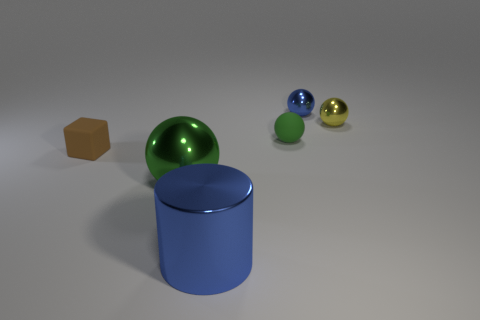How many things are either objects that are in front of the brown thing or shiny objects that are behind the brown matte object?
Provide a succinct answer. 4. Does the green sphere that is in front of the green rubber object have the same size as the tiny rubber ball?
Your answer should be very brief. No. There is a green metallic thing that is the same shape as the small blue metal object; what size is it?
Provide a short and direct response. Large. There is a blue cylinder that is the same size as the green metallic sphere; what material is it?
Ensure brevity in your answer.  Metal. There is a blue thing that is the same shape as the yellow metal thing; what material is it?
Offer a very short reply. Metal. How many other objects are the same size as the block?
Give a very brief answer. 3. There is a object that is the same color as the big shiny cylinder; what is its size?
Ensure brevity in your answer.  Small. What number of large objects have the same color as the large metallic cylinder?
Provide a short and direct response. 0. What shape is the large blue thing?
Offer a very short reply. Cylinder. The object that is right of the small brown rubber object and on the left side of the cylinder is what color?
Your answer should be compact. Green. 